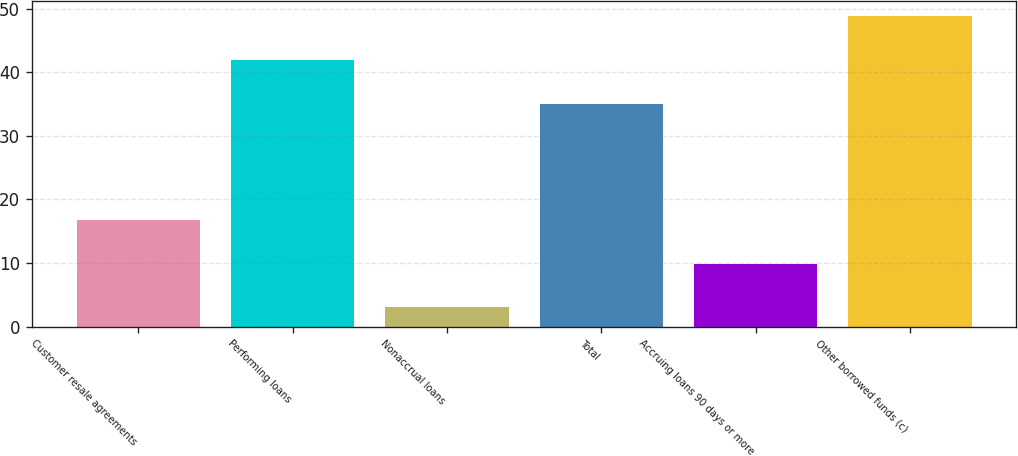<chart> <loc_0><loc_0><loc_500><loc_500><bar_chart><fcel>Customer resale agreements<fcel>Performing loans<fcel>Nonaccrual loans<fcel>Total<fcel>Accruing loans 90 days or more<fcel>Other borrowed funds (c)<nl><fcel>16.8<fcel>41.9<fcel>3<fcel>35<fcel>9.9<fcel>48.8<nl></chart> 